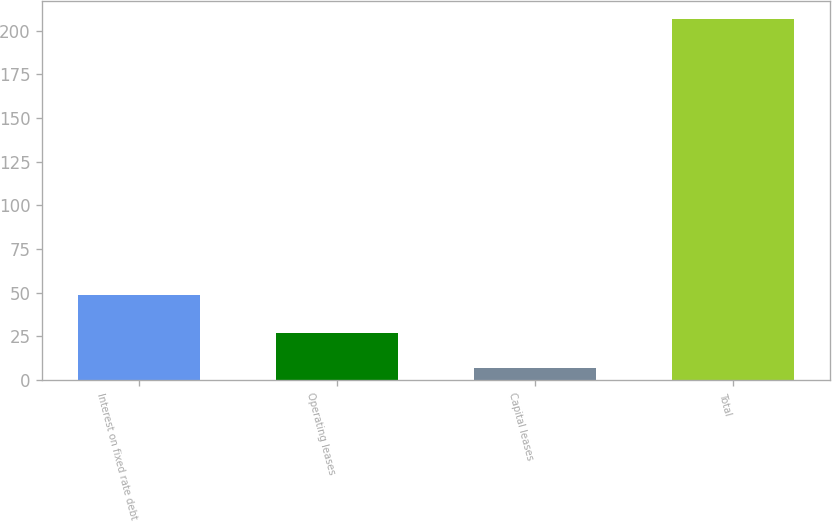Convert chart. <chart><loc_0><loc_0><loc_500><loc_500><bar_chart><fcel>Interest on fixed rate debt<fcel>Operating leases<fcel>Capital leases<fcel>Total<nl><fcel>48.6<fcel>26.82<fcel>6.8<fcel>207<nl></chart> 